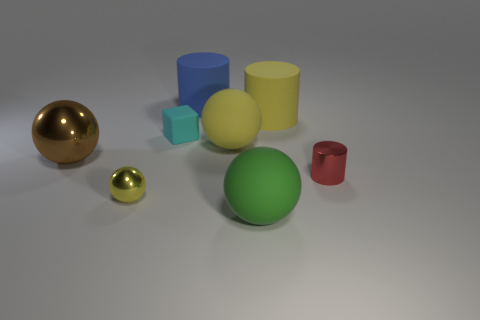Subtract all yellow blocks. How many yellow spheres are left? 2 Subtract 1 cylinders. How many cylinders are left? 2 Subtract all rubber cylinders. How many cylinders are left? 1 Subtract all brown spheres. How many spheres are left? 3 Add 2 big blue objects. How many objects exist? 10 Subtract all blue balls. Subtract all gray cylinders. How many balls are left? 4 Subtract all cylinders. How many objects are left? 5 Add 8 big green spheres. How many big green spheres are left? 9 Add 3 large blue cubes. How many large blue cubes exist? 3 Subtract 0 purple blocks. How many objects are left? 8 